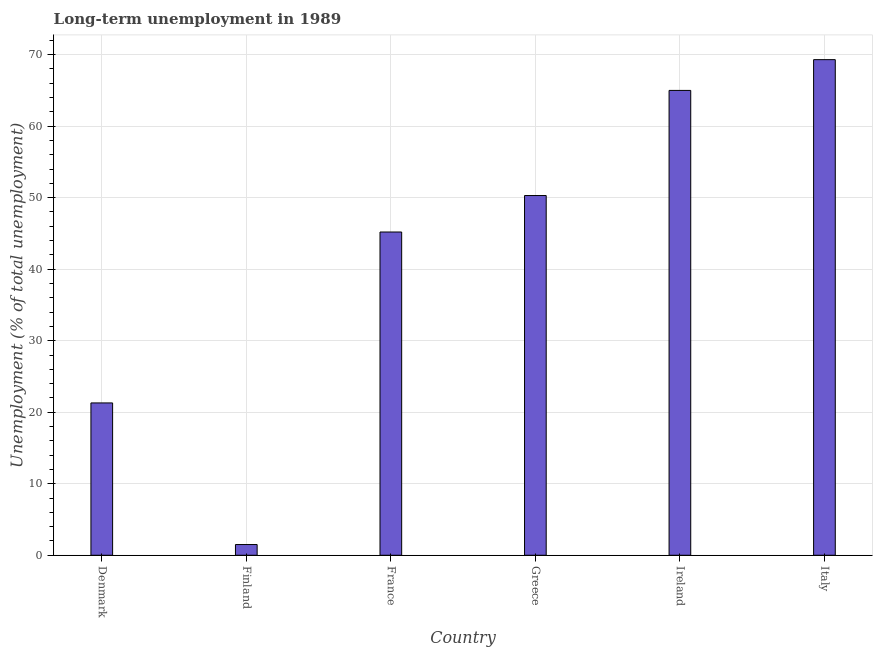Does the graph contain any zero values?
Your answer should be compact. No. Does the graph contain grids?
Your answer should be compact. Yes. What is the title of the graph?
Your answer should be compact. Long-term unemployment in 1989. What is the label or title of the X-axis?
Keep it short and to the point. Country. What is the label or title of the Y-axis?
Make the answer very short. Unemployment (% of total unemployment). What is the long-term unemployment in Greece?
Give a very brief answer. 50.3. Across all countries, what is the maximum long-term unemployment?
Make the answer very short. 69.3. In which country was the long-term unemployment maximum?
Provide a succinct answer. Italy. In which country was the long-term unemployment minimum?
Your answer should be very brief. Finland. What is the sum of the long-term unemployment?
Offer a very short reply. 252.6. What is the difference between the long-term unemployment in Denmark and France?
Make the answer very short. -23.9. What is the average long-term unemployment per country?
Provide a succinct answer. 42.1. What is the median long-term unemployment?
Provide a short and direct response. 47.75. In how many countries, is the long-term unemployment greater than 26 %?
Make the answer very short. 4. What is the ratio of the long-term unemployment in Denmark to that in Greece?
Keep it short and to the point. 0.42. Is the long-term unemployment in Ireland less than that in Italy?
Provide a short and direct response. Yes. Is the difference between the long-term unemployment in Denmark and France greater than the difference between any two countries?
Offer a terse response. No. What is the difference between the highest and the lowest long-term unemployment?
Your answer should be compact. 67.8. Are all the bars in the graph horizontal?
Provide a succinct answer. No. What is the difference between two consecutive major ticks on the Y-axis?
Your response must be concise. 10. Are the values on the major ticks of Y-axis written in scientific E-notation?
Provide a short and direct response. No. What is the Unemployment (% of total unemployment) of Denmark?
Your answer should be very brief. 21.3. What is the Unemployment (% of total unemployment) in France?
Offer a terse response. 45.2. What is the Unemployment (% of total unemployment) in Greece?
Provide a succinct answer. 50.3. What is the Unemployment (% of total unemployment) of Ireland?
Your response must be concise. 65. What is the Unemployment (% of total unemployment) of Italy?
Provide a succinct answer. 69.3. What is the difference between the Unemployment (% of total unemployment) in Denmark and Finland?
Ensure brevity in your answer.  19.8. What is the difference between the Unemployment (% of total unemployment) in Denmark and France?
Provide a succinct answer. -23.9. What is the difference between the Unemployment (% of total unemployment) in Denmark and Ireland?
Provide a succinct answer. -43.7. What is the difference between the Unemployment (% of total unemployment) in Denmark and Italy?
Offer a very short reply. -48. What is the difference between the Unemployment (% of total unemployment) in Finland and France?
Offer a very short reply. -43.7. What is the difference between the Unemployment (% of total unemployment) in Finland and Greece?
Make the answer very short. -48.8. What is the difference between the Unemployment (% of total unemployment) in Finland and Ireland?
Provide a succinct answer. -63.5. What is the difference between the Unemployment (% of total unemployment) in Finland and Italy?
Provide a succinct answer. -67.8. What is the difference between the Unemployment (% of total unemployment) in France and Greece?
Make the answer very short. -5.1. What is the difference between the Unemployment (% of total unemployment) in France and Ireland?
Provide a succinct answer. -19.8. What is the difference between the Unemployment (% of total unemployment) in France and Italy?
Give a very brief answer. -24.1. What is the difference between the Unemployment (% of total unemployment) in Greece and Ireland?
Your answer should be compact. -14.7. What is the difference between the Unemployment (% of total unemployment) in Greece and Italy?
Your answer should be compact. -19. What is the difference between the Unemployment (% of total unemployment) in Ireland and Italy?
Make the answer very short. -4.3. What is the ratio of the Unemployment (% of total unemployment) in Denmark to that in France?
Your response must be concise. 0.47. What is the ratio of the Unemployment (% of total unemployment) in Denmark to that in Greece?
Offer a terse response. 0.42. What is the ratio of the Unemployment (% of total unemployment) in Denmark to that in Ireland?
Ensure brevity in your answer.  0.33. What is the ratio of the Unemployment (% of total unemployment) in Denmark to that in Italy?
Make the answer very short. 0.31. What is the ratio of the Unemployment (% of total unemployment) in Finland to that in France?
Make the answer very short. 0.03. What is the ratio of the Unemployment (% of total unemployment) in Finland to that in Greece?
Your answer should be very brief. 0.03. What is the ratio of the Unemployment (% of total unemployment) in Finland to that in Ireland?
Offer a terse response. 0.02. What is the ratio of the Unemployment (% of total unemployment) in Finland to that in Italy?
Offer a terse response. 0.02. What is the ratio of the Unemployment (% of total unemployment) in France to that in Greece?
Your answer should be very brief. 0.9. What is the ratio of the Unemployment (% of total unemployment) in France to that in Ireland?
Your answer should be very brief. 0.69. What is the ratio of the Unemployment (% of total unemployment) in France to that in Italy?
Provide a short and direct response. 0.65. What is the ratio of the Unemployment (% of total unemployment) in Greece to that in Ireland?
Keep it short and to the point. 0.77. What is the ratio of the Unemployment (% of total unemployment) in Greece to that in Italy?
Offer a terse response. 0.73. What is the ratio of the Unemployment (% of total unemployment) in Ireland to that in Italy?
Provide a short and direct response. 0.94. 